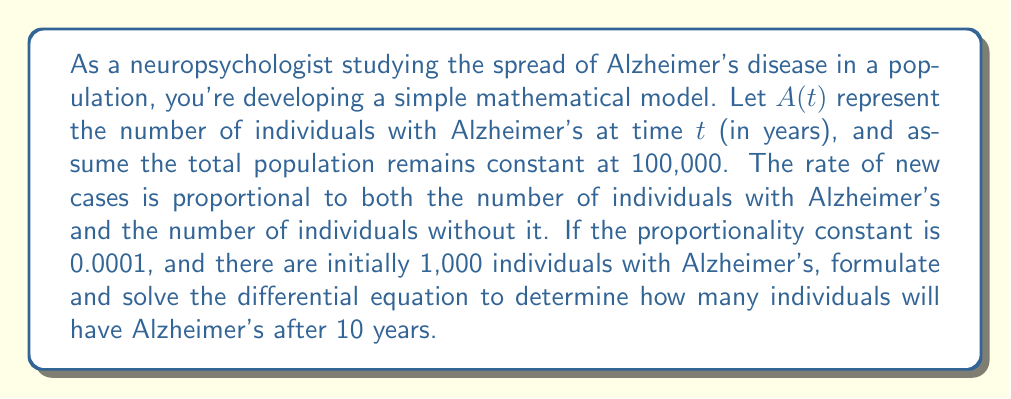Show me your answer to this math problem. Let's approach this step-by-step:

1) First, we need to formulate the differential equation. The rate of change of $A(t)$ is proportional to $A(t)$ and $(100000 - A(t))$:

   $$\frac{dA}{dt} = 0.0001 \cdot A(t) \cdot (100000 - A(t))$$

2) This is a separable differential equation. Let's rearrange it:

   $$\frac{dA}{A(100000 - A)} = 0.0001 \cdot dt$$

3) Integrate both sides:

   $$\int \frac{dA}{A(100000 - A)} = \int 0.0001 \cdot dt$$

4) The left side can be integrated using partial fractions:

   $$\frac{1}{100000} \ln\left|\frac{A}{100000 - A}\right| = 0.0001t + C$$

5) Use the initial condition: $A(0) = 1000$

   $$\frac{1}{100000} \ln\left|\frac{1000}{99000}\right| = C$$

6) Substitute this back into the general solution:

   $$\frac{1}{100000} \ln\left|\frac{A}{100000 - A}\right| = 0.0001t + \frac{1}{100000} \ln\left|\frac{1000}{99000}\right|$$

7) Simplify and solve for $A$:

   $$\frac{A}{100000 - A} = \frac{1000}{99000} e^{10t}$$

   $$A = \frac{100000}{1 + 99e^{-10t}}$$

8) To find $A(10)$, substitute $t = 10$:

   $$A(10) = \frac{100000}{1 + 99e^{-100}} \approx 36,788$$
Answer: After 10 years, approximately 36,788 individuals will have Alzheimer's disease. 